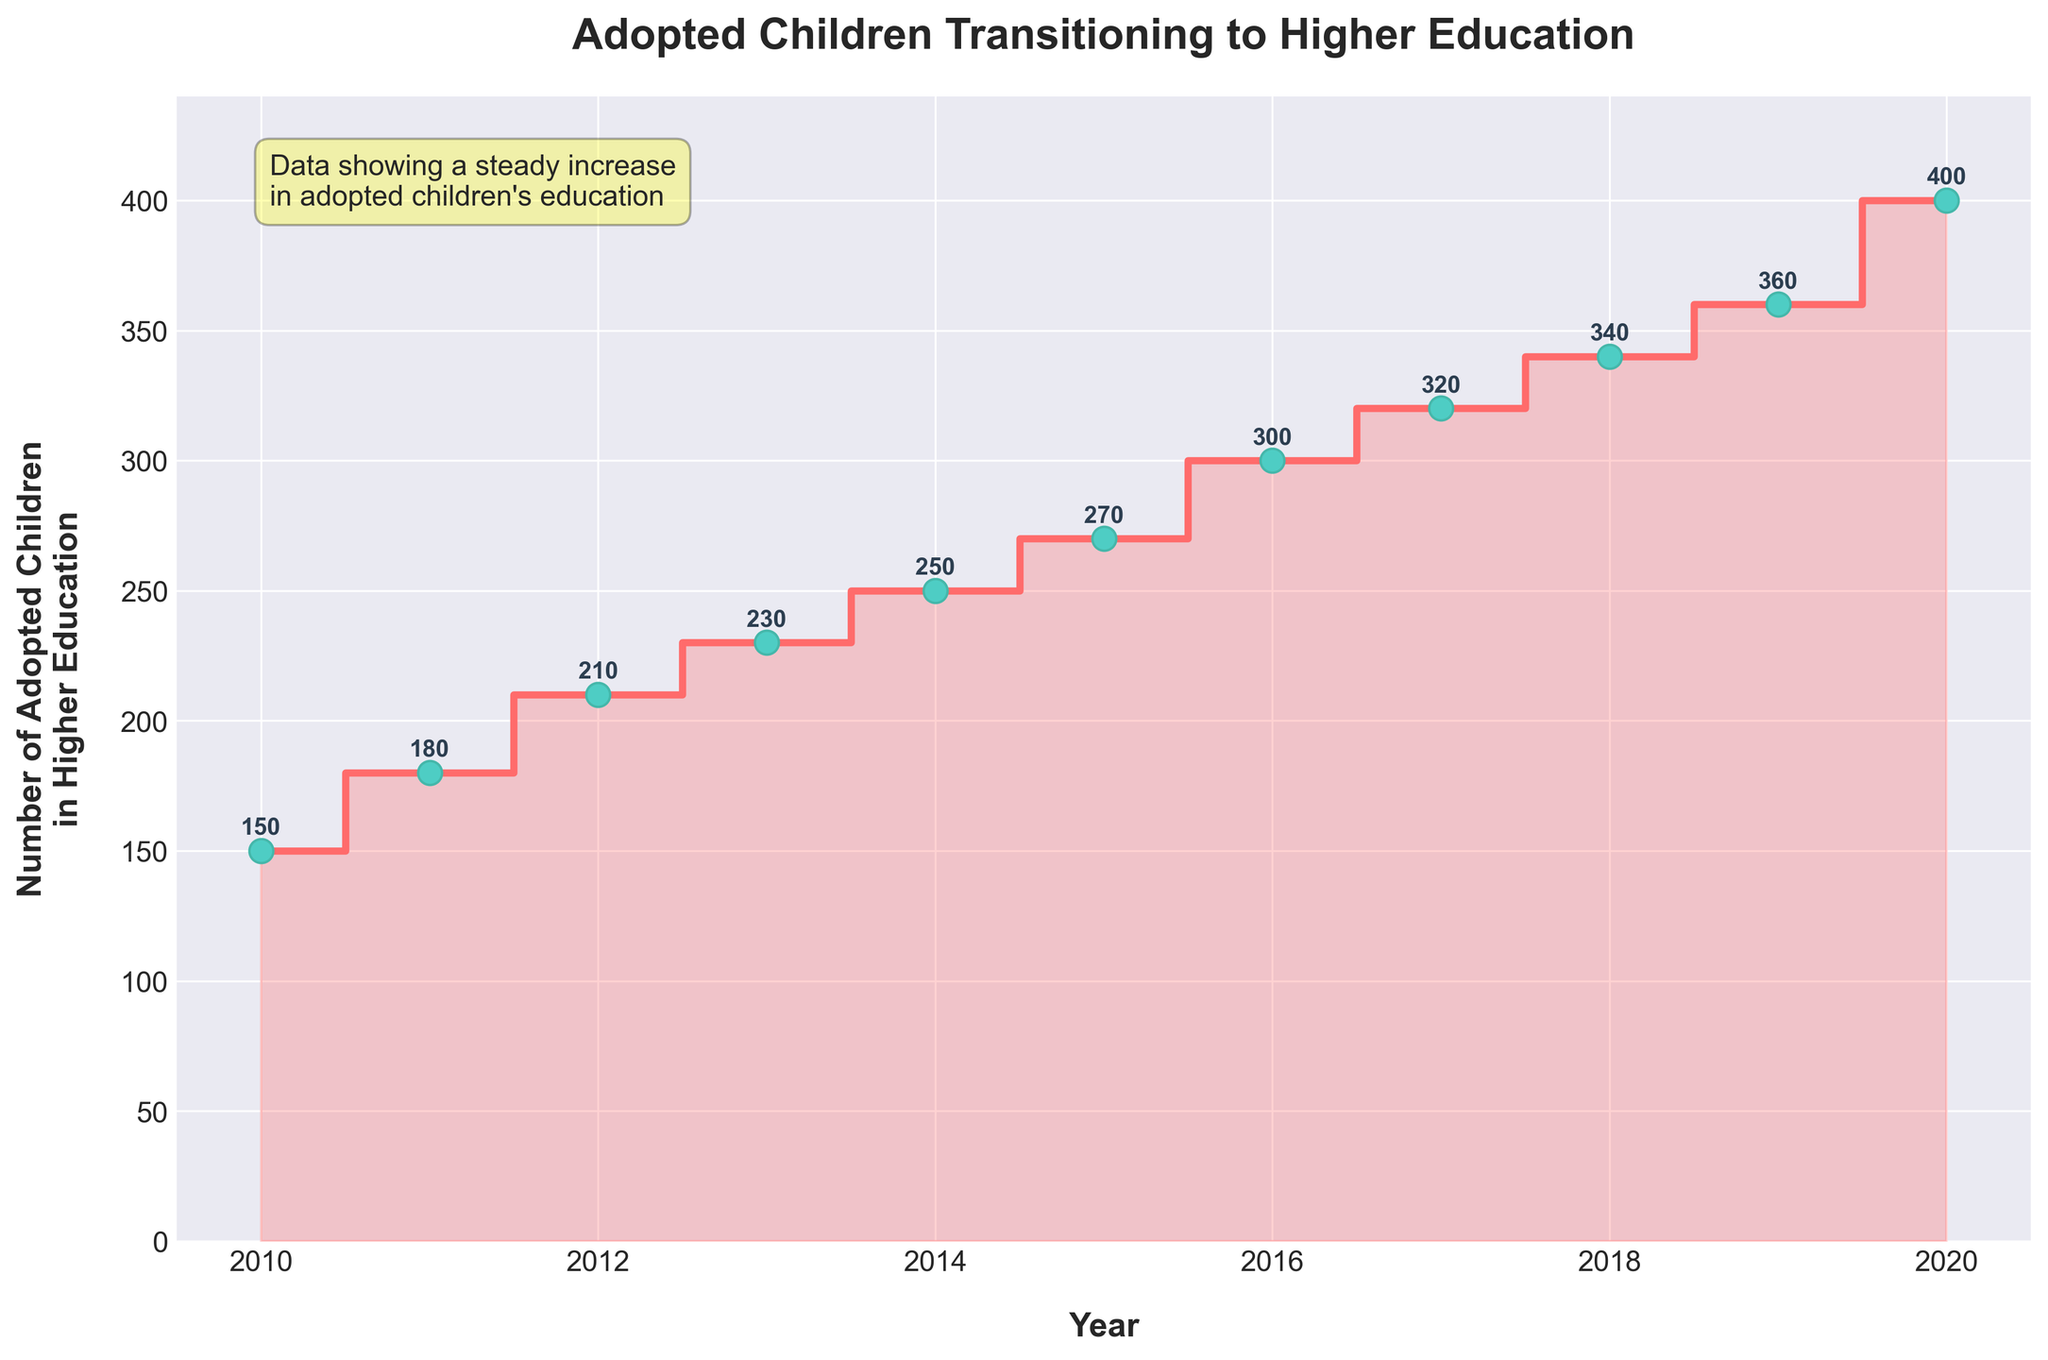what is the title of the figure? The title is visible at the top of the plot and it reads "Adopted Children Transitioning to Higher Education". This title provides a summary of what the plot is about.
Answer: Adopted Children Transitioning to Higher Education How many children transitioned to higher education in 2015? Locate the point corresponding to the year 2015 and find its value. This can be done by following the line upward from 2015 on the x-axis to find the number of adopted children. The figure directly shows that the value is 270.
Answer: 270 In which year did the number of adopted children in higher education reach 400? Find the y-axis value of 400 and trace it horizontally to the mid-step mark that aligns with 400. Then, look at the corresponding x-axis value, which shows the year. The plot indicates that this occurred in 2020.
Answer: 2020 What is the increase in the number of children transitioning to higher education from 2016 to 2019? Note the values for 2016 and 2019, which are 300 and 360 respectively. The increase is calculated by subtracting the 2016 value from the 2019 value: 360 - 300 = 60.
Answer: 60 Which year saw the highest number of adopted children transitioning to higher education? This can be determined by identifying the maximum value on the plot. The figure shows that the highest value is 400, which corresponds to the year 2020.
Answer: 2020 Compare the number of children transitioning to higher education between 2012 and 2013. Look at the values for 2012 and 2013, which are 210 and 230 respectively. Compare these values directly: 230 (2013) is greater than 210 (2012).
Answer: 2013 > 2012 What is the average number of adopted children transitioning to higher education from 2018 to 2020? Find the values for 2018, 2019, and 2020: 340, 360, and 400. Sum these values and divide by the number of years: (340 + 360 + 400) / 3 = 1100 / 3 ≈ 367.
Answer: 367 How did the number of children transitioning to higher education change from 2010 to 2020? Examine the values for 2010 and 2020, which are 150 and 400 respectively. The change is calculated by subtracting the 2010 value from the 2020 value: 400 - 150 = 250.
Answer: Increased by 250 What is the trend indicated by the data from 2010 to 2020? Observing the overall pattern from 2010 to 2020, we see a consistent upward trend without any decreases, showing a steady increase in the number of adopted children transitioning to higher education each year.
Answer: Steady increase 